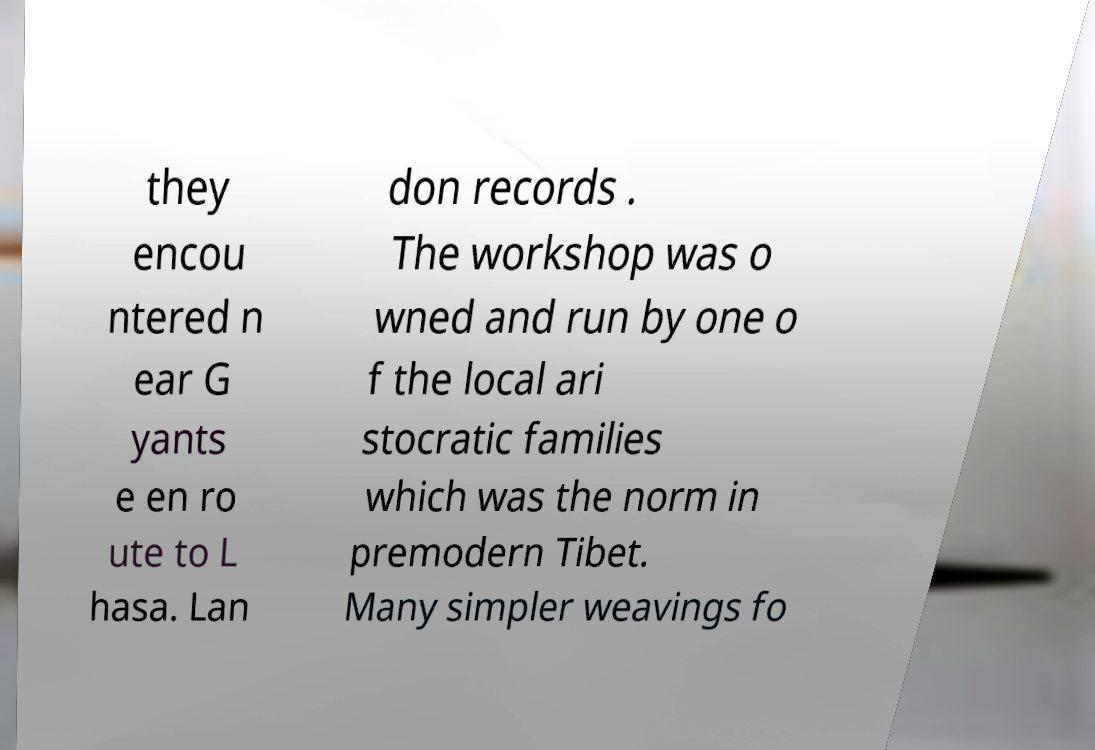Could you assist in decoding the text presented in this image and type it out clearly? they encou ntered n ear G yants e en ro ute to L hasa. Lan don records . The workshop was o wned and run by one o f the local ari stocratic families which was the norm in premodern Tibet. Many simpler weavings fo 